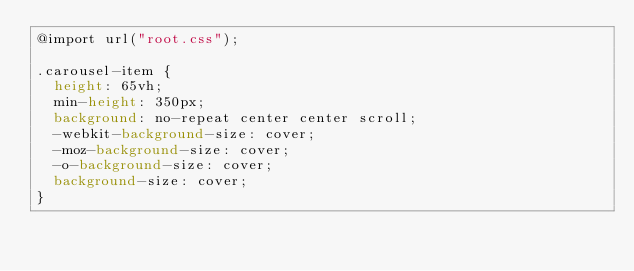Convert code to text. <code><loc_0><loc_0><loc_500><loc_500><_CSS_>@import url("root.css");

.carousel-item {
  height: 65vh;
  min-height: 350px;
  background: no-repeat center center scroll;
  -webkit-background-size: cover;
  -moz-background-size: cover;
  -o-background-size: cover;
  background-size: cover;
}</code> 